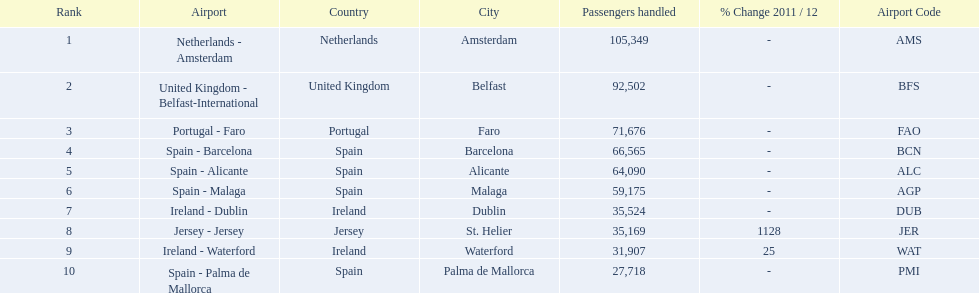Looking at the top 10 busiest routes to and from london southend airport what is the average number of passengers handled? 58,967.5. I'm looking to parse the entire table for insights. Could you assist me with that? {'header': ['Rank', 'Airport', 'Country', 'City', 'Passengers handled', '% Change 2011 / 12', 'Airport Code'], 'rows': [['1', 'Netherlands - Amsterdam', 'Netherlands', 'Amsterdam', '105,349', '-', 'AMS'], ['2', 'United Kingdom - Belfast-International', 'United Kingdom', 'Belfast', '92,502', '-', 'BFS'], ['3', 'Portugal - Faro', 'Portugal', 'Faro', '71,676', '-', 'FAO'], ['4', 'Spain - Barcelona', 'Spain', 'Barcelona', '66,565', '-', 'BCN'], ['5', 'Spain - Alicante', 'Spain', 'Alicante', '64,090', '-', 'ALC'], ['6', 'Spain - Malaga', 'Spain', 'Malaga', '59,175', '-', 'AGP'], ['7', 'Ireland - Dublin', 'Ireland', 'Dublin', '35,524', '-', 'DUB'], ['8', 'Jersey - Jersey', 'Jersey', 'St. Helier', '35,169', '1128', 'JER'], ['9', 'Ireland - Waterford', 'Ireland', 'Waterford', '31,907', '25', 'WAT'], ['10', 'Spain - Palma de Mallorca', 'Spain', 'Palma de Mallorca', '27,718', '-', 'PMI']]} 